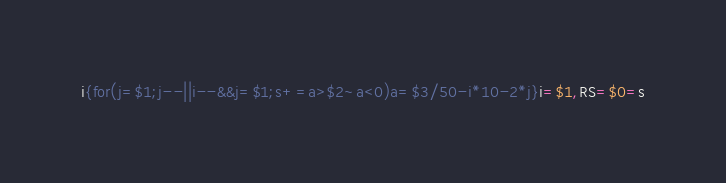<code> <loc_0><loc_0><loc_500><loc_500><_Pascal_>i{for(j=$1;j--||i--&&j=$1;s+=a>$2~a<0)a=$3/50-i*10-2*j}i=$1,RS=$0=s</code> 